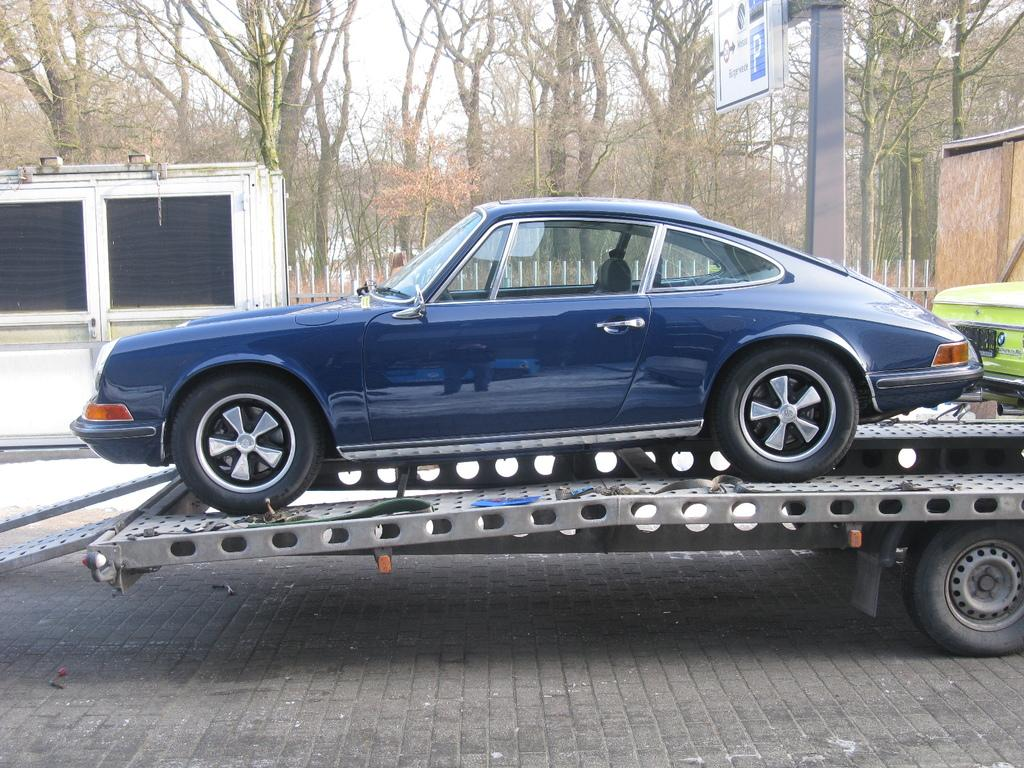What types of vehicles can be seen on the ground in the image? There are vehicles on the ground in the image, but the specific types are not mentioned. What is the purpose of the signboard in the image? The purpose of the signboard in the image is not mentioned, but it could be providing information or directions. What is the pole in the image used for? The purpose of the pole in the image is not mentioned, but it could be supporting a sign, light, or other object. What type of vegetation is present in the image? There are trees in the image, which indicates the presence of vegetation. Can you describe the objects in the image? The specific objects in the image are not mentioned, but they could be related to the vehicles, signboard, or pole. What can be seen in the background of the image? The sky is visible in the background of the image. How many horses are present in the image? There are no horses present in the image. What type of account is being discussed in the image? There is no account being discussed in the image. 